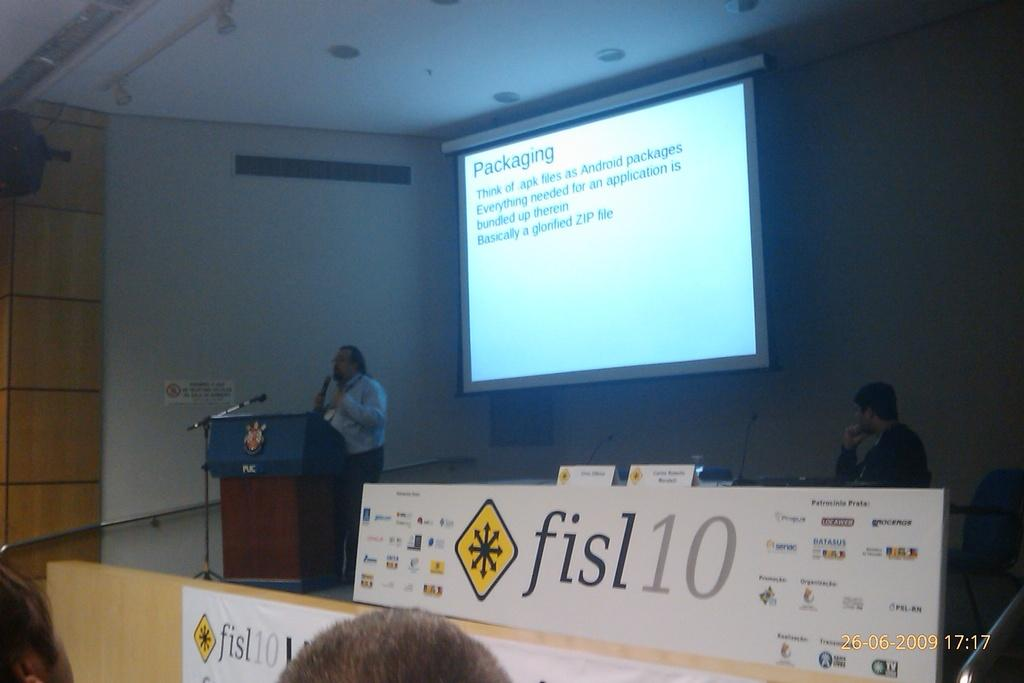What is the person in the image doing? There is a person standing in front of the podium in the image. What is the person likely to use to address the audience? There is a mic in the image, which the person might use to speak. What is the person standing near? There is a stand in the image, which might be used to hold notes or other materials. What is on the stage with the person? There is a white color board on the stage. What is visible in the background of the image? There is a screen and a white color wall in the background of the image. Can you see any bushes or the ocean in the image? No, there are no bushes or ocean visible in the image. Is there a market present in the image? No, there is no market present in the image. 